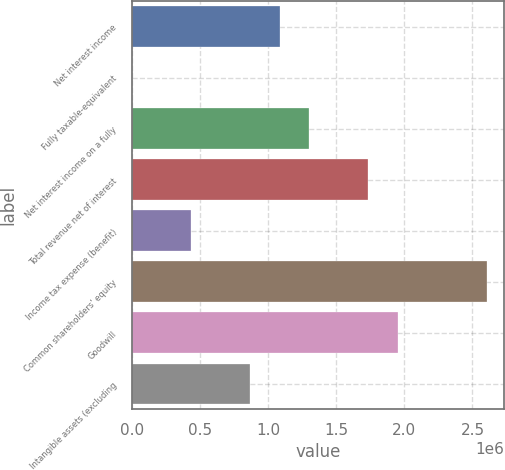<chart> <loc_0><loc_0><loc_500><loc_500><bar_chart><fcel>Net interest income<fcel>Fully taxable-equivalent<fcel>Net interest income on a fully<fcel>Total revenue net of interest<fcel>Income tax expense (benefit)<fcel>Common shareholders' equity<fcel>Goodwill<fcel>Intangible assets (excluding<nl><fcel>1.08538e+06<fcel>213<fcel>1.30242e+06<fcel>1.73649e+06<fcel>434282<fcel>2.60463e+06<fcel>1.95352e+06<fcel>868351<nl></chart> 